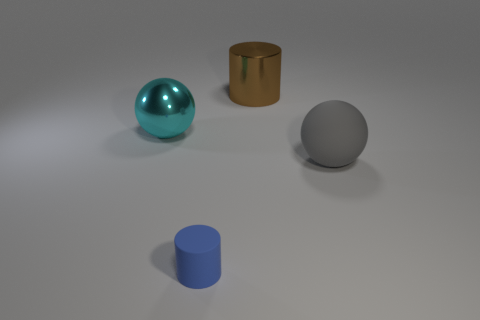Subtract all blue cylinders. How many cylinders are left? 1 Add 2 large metallic spheres. How many large metallic spheres exist? 3 Add 4 matte objects. How many objects exist? 8 Subtract 0 yellow cylinders. How many objects are left? 4 Subtract 1 spheres. How many spheres are left? 1 Subtract all purple cylinders. Subtract all green spheres. How many cylinders are left? 2 Subtract all yellow spheres. How many yellow cylinders are left? 0 Subtract all big cylinders. Subtract all matte balls. How many objects are left? 2 Add 4 tiny matte objects. How many tiny matte objects are left? 5 